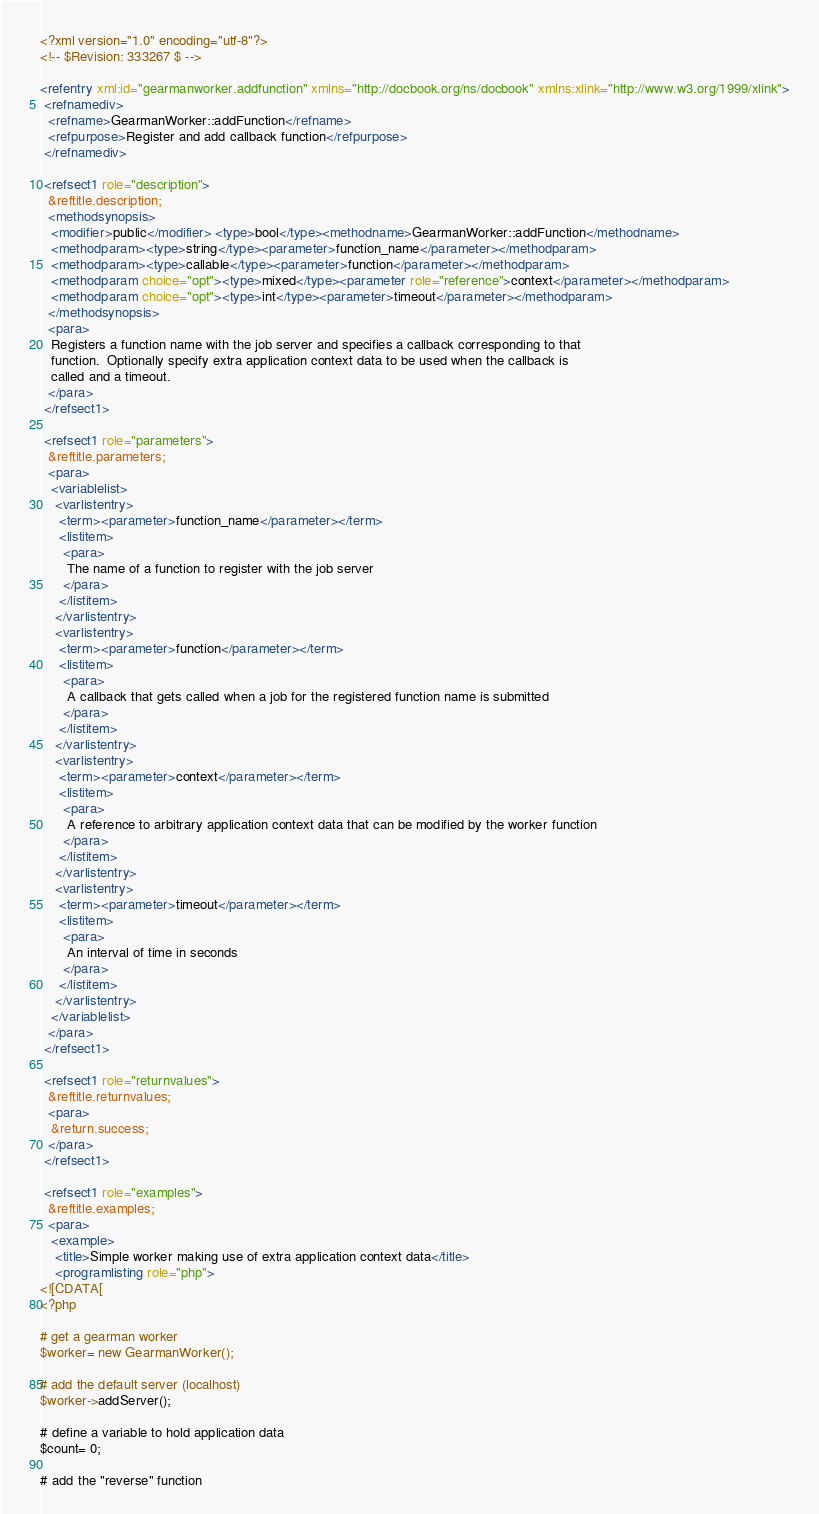<code> <loc_0><loc_0><loc_500><loc_500><_XML_><?xml version="1.0" encoding="utf-8"?>
<!-- $Revision: 333267 $ -->

<refentry xml:id="gearmanworker.addfunction" xmlns="http://docbook.org/ns/docbook" xmlns:xlink="http://www.w3.org/1999/xlink">
 <refnamediv>
  <refname>GearmanWorker::addFunction</refname>
  <refpurpose>Register and add callback function</refpurpose>
 </refnamediv>

 <refsect1 role="description">
  &reftitle.description;
  <methodsynopsis>
   <modifier>public</modifier> <type>bool</type><methodname>GearmanWorker::addFunction</methodname>
   <methodparam><type>string</type><parameter>function_name</parameter></methodparam>
   <methodparam><type>callable</type><parameter>function</parameter></methodparam>
   <methodparam choice="opt"><type>mixed</type><parameter role="reference">context</parameter></methodparam>
   <methodparam choice="opt"><type>int</type><parameter>timeout</parameter></methodparam>
  </methodsynopsis>
  <para>
   Registers a function name with the job server and specifies a callback corresponding to that
   function.  Optionally specify extra application context data to be used when the callback is
   called and a timeout.
  </para>
 </refsect1>

 <refsect1 role="parameters">
  &reftitle.parameters;
  <para>
   <variablelist>
    <varlistentry>
     <term><parameter>function_name</parameter></term>
     <listitem>
      <para>
       The name of a function to register with the job server
      </para>
     </listitem>
    </varlistentry>
    <varlistentry>
     <term><parameter>function</parameter></term>
     <listitem>
      <para>
       A callback that gets called when a job for the registered function name is submitted
      </para>
     </listitem>
    </varlistentry>
    <varlistentry>
     <term><parameter>context</parameter></term>
     <listitem>
      <para>
       A reference to arbitrary application context data that can be modified by the worker function
      </para>
     </listitem>
    </varlistentry>
    <varlistentry>
     <term><parameter>timeout</parameter></term>
     <listitem>
      <para>
       An interval of time in seconds
      </para>
     </listitem>
    </varlistentry>
   </variablelist>
  </para>
 </refsect1>

 <refsect1 role="returnvalues">
  &reftitle.returnvalues;
  <para>
   &return.success;
  </para>
 </refsect1>

 <refsect1 role="examples">
  &reftitle.examples;
  <para>
   <example>
    <title>Simple worker making use of extra application context data</title>
    <programlisting role="php">
<![CDATA[
<?php

# get a gearman worker
$worker= new GearmanWorker(); 

# add the default server (localhost)
$worker->addServer(); 

# define a variable to hold application data
$count= 0; 

# add the "reverse" function</code> 